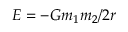Convert formula to latex. <formula><loc_0><loc_0><loc_500><loc_500>E = - G m _ { 1 } m _ { 2 } / 2 r</formula> 